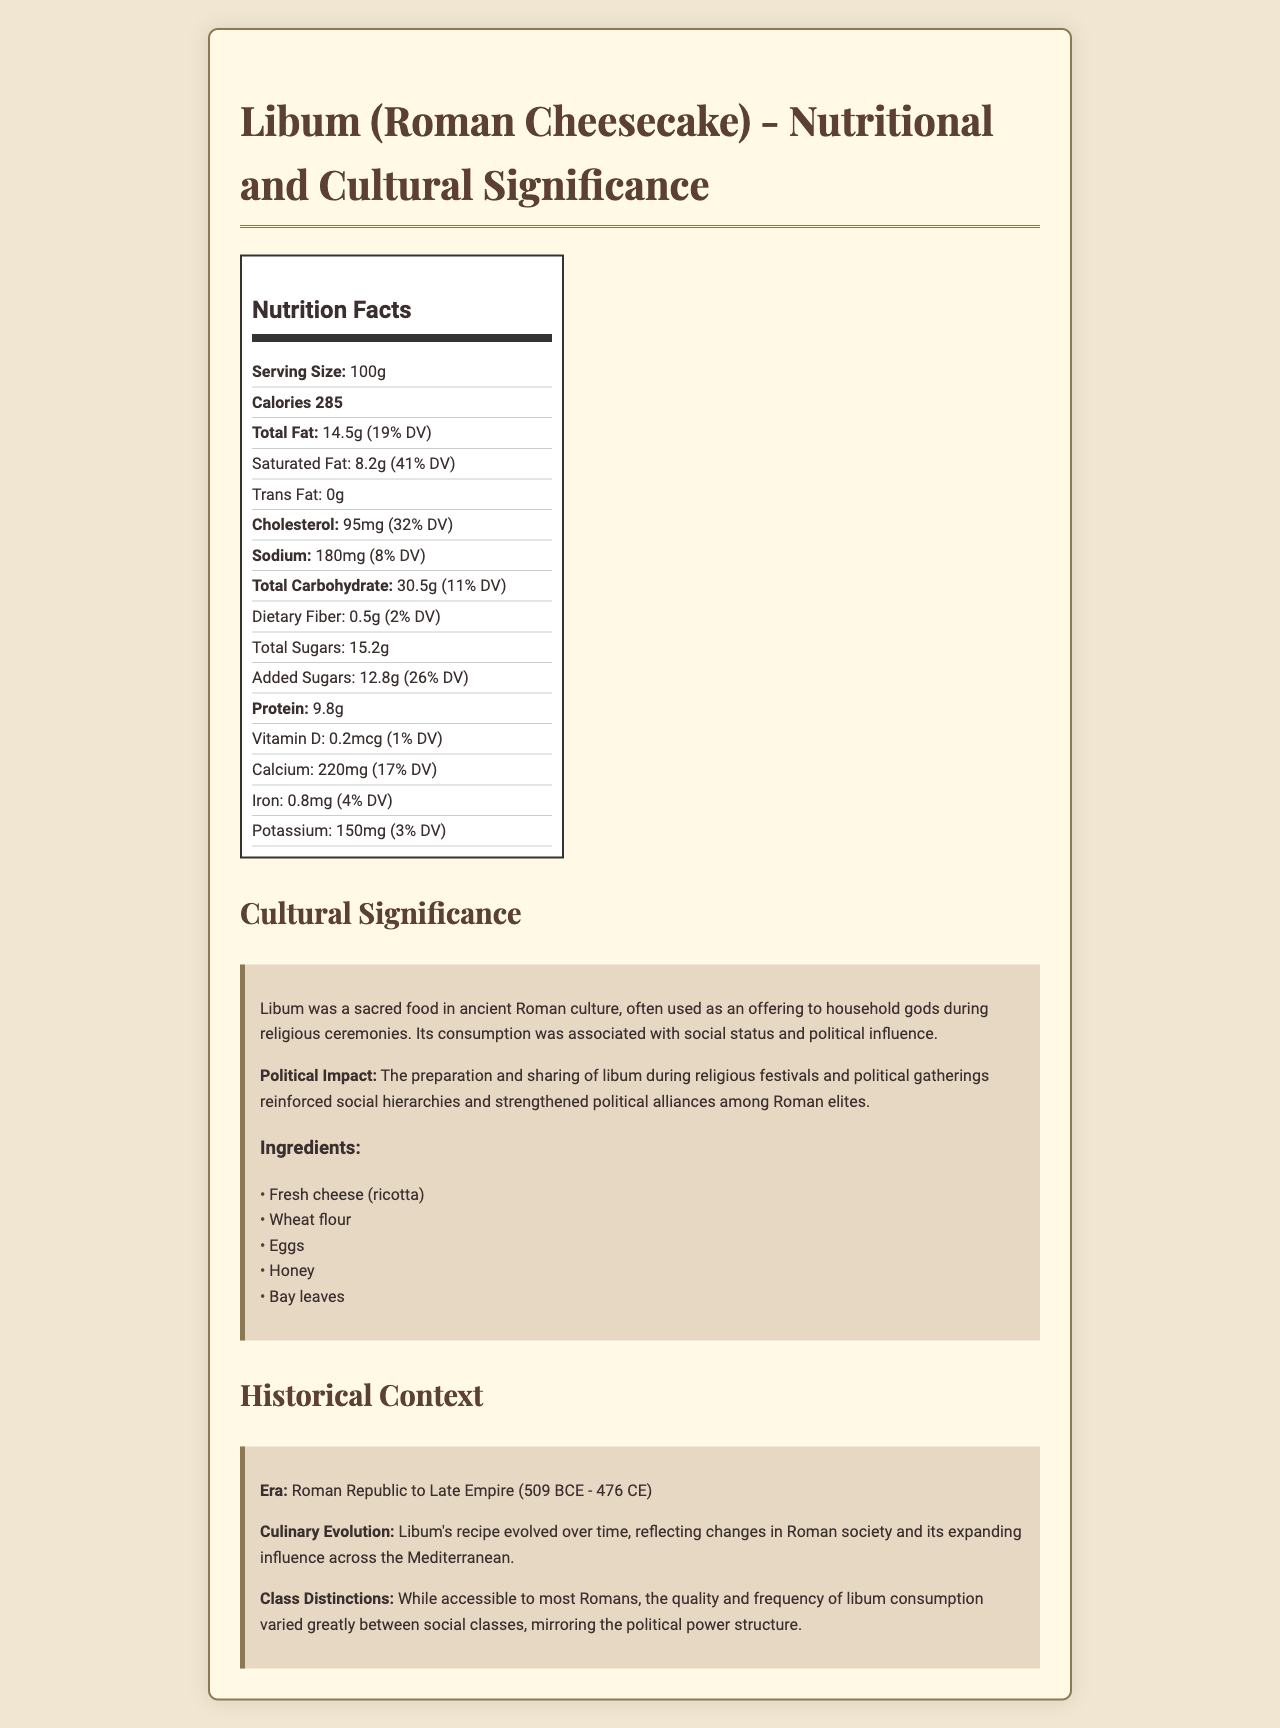what is the serving size for Libum? The serving size is clearly stated in the nutrition label as 100g.
Answer: 100g how many calories are in one serving of Libum? The nutrition label specifies that one serving of Libum contains 285 calories.
Answer: 285 how much total fat is in one serving of Libum? The nutrition label reports that one serving of Libum contains 14.5 grams of total fat.
Answer: 14.5g how much saturated fat does Libum contain per serving? The nutrition label shows that Libum contains 8.2 grams of saturated fat per serving.
Answer: 8.2g which ingredient is not listed in the nutritional composition of Libum? A. Fresh cheese B. Olive oil C. Wheat flour D. Honey The ingredients listed are Fresh cheese (ricotta), Wheat flour, Eggs, Honey, Bay leaves; Olive oil is not included.
Answer: B what is the percentage daily value of cholesterol in Libum? The nutrition label states that Libum contains 95mg of cholesterol, which is 32% of the daily value.
Answer: 32% does Libum contain any trans fat? The nutrition label specifies 0 grams of trans fat.
Answer: No how much potassium is in one serving of Libum? The nutrition label indicates that one serving of Libum contains 150mg of potassium.
Answer: 150mg describe the cultural significance of Libum in Ancient Rome. The document describes Libum as a sacred food integral to religious ceremonies, associated with social status and political influence, used to strengthen political alliances among Roman elites.
Answer: Libum was a sacred food in ancient Roman culture, often used as an offering to household gods during religious ceremonies. Its consumption was associated with social status and political influence. during which era was Libum consumed? The historical context section mentions that Libum was consumed from the Roman Republic to the Late Empire.
Answer: Roman Republic to Late Empire (509 BCE - 476 CE) how did the popularity and quality of Libum vary between social classes in ancient Rome? The document explains that, while Libum was accessible to most Romans, its quality and consumption frequency varied significantly across social classes, reflecting the political hierarchy.
Answer: The quality and frequency of Libum consumption varied greatly between social classes, mirroring the political power structure. what percentage of the daily value for sodium does Libum provide? According to the nutrition label, one serving of Libum provides 180mg of sodium, which is 8% of the daily value.
Answer: 8% which of the following nutrients does Libum provide the highest daily value percentage of? A. Vitamin D B. Calcium C. Iron The nutrition label shows that Libum provides 17% of the daily value for calcium, which is higher than that of Vitamin D (1%) and Iron (4%).
Answer: B is the exact recipe of Libum given in the document? The document mentions the ingredients but does not provide the exact recipe of Libum.
Answer: No what is the political impact of Libum as mentioned in the document? The cultural significance section specifies that the preparation and sharing of Libum during significant events reinforced social hierarchies and political alliances.
Answer: The preparation and sharing of libum during religious festivals and political gatherings reinforced social hierarchies and strengthened political alliances among Roman elites. how much dietary fiber does Libum contain per serving? The nutrition label states that there is 0.5 grams of dietary fiber per serving of Libum.
Answer: 0.5g 